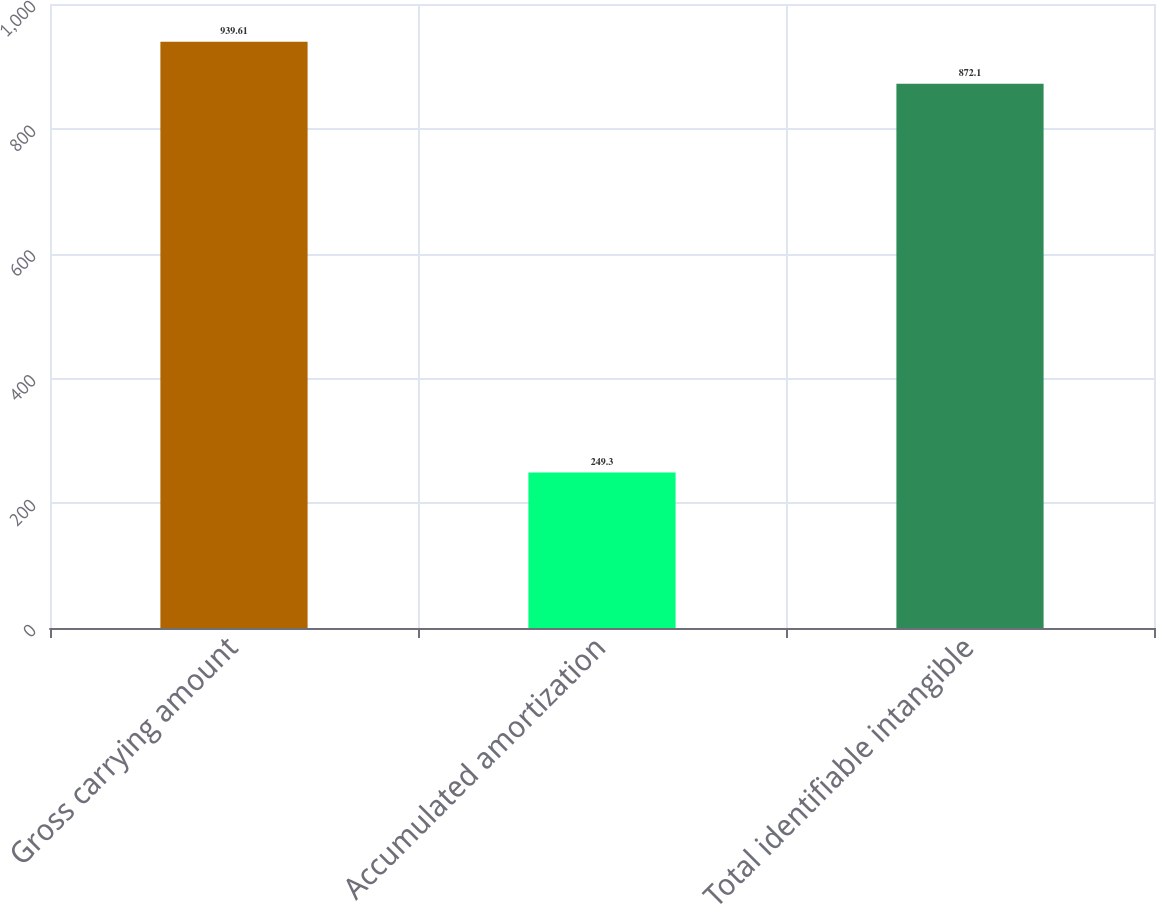Convert chart. <chart><loc_0><loc_0><loc_500><loc_500><bar_chart><fcel>Gross carrying amount<fcel>Accumulated amortization<fcel>Total identifiable intangible<nl><fcel>939.61<fcel>249.3<fcel>872.1<nl></chart> 